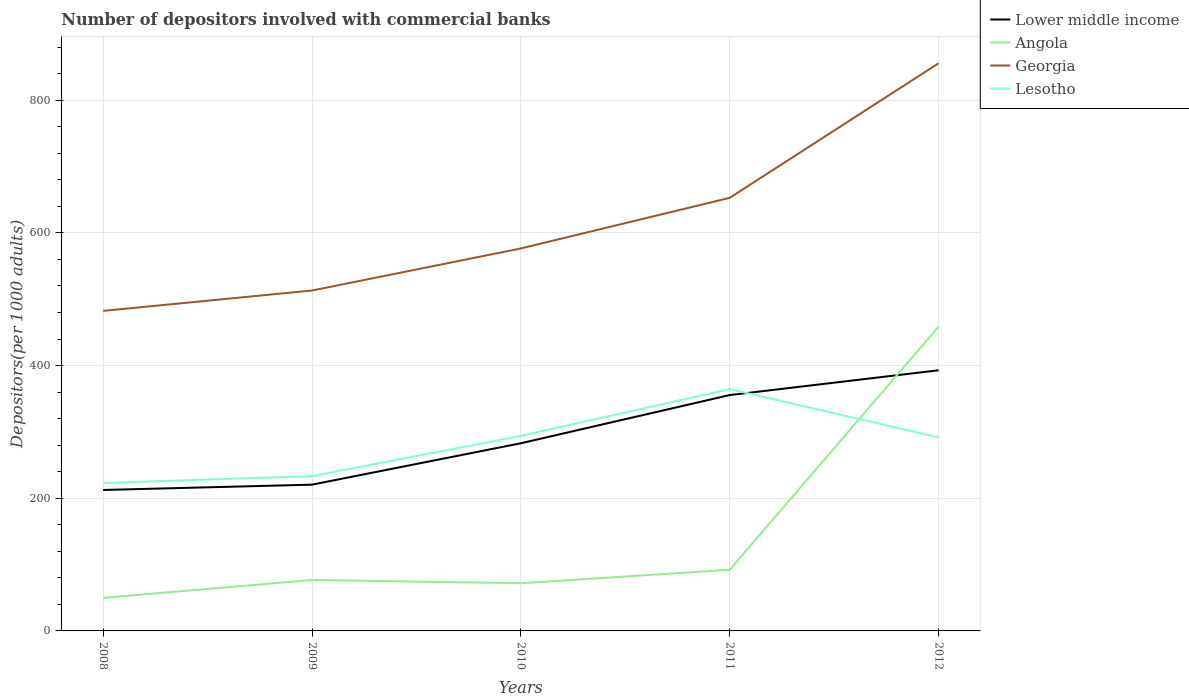How many different coloured lines are there?
Your response must be concise. 4. Does the line corresponding to Georgia intersect with the line corresponding to Lesotho?
Offer a terse response. No. Across all years, what is the maximum number of depositors involved with commercial banks in Angola?
Your answer should be compact. 49.81. In which year was the number of depositors involved with commercial banks in Georgia maximum?
Give a very brief answer. 2008. What is the total number of depositors involved with commercial banks in Georgia in the graph?
Your answer should be very brief. -202.83. What is the difference between the highest and the second highest number of depositors involved with commercial banks in Angola?
Your answer should be compact. 408.87. What is the difference between the highest and the lowest number of depositors involved with commercial banks in Lesotho?
Your response must be concise. 3. How many years are there in the graph?
Your response must be concise. 5. Are the values on the major ticks of Y-axis written in scientific E-notation?
Provide a succinct answer. No. Does the graph contain any zero values?
Your answer should be very brief. No. Where does the legend appear in the graph?
Keep it short and to the point. Top right. What is the title of the graph?
Offer a terse response. Number of depositors involved with commercial banks. What is the label or title of the X-axis?
Provide a short and direct response. Years. What is the label or title of the Y-axis?
Ensure brevity in your answer.  Depositors(per 1000 adults). What is the Depositors(per 1000 adults) in Lower middle income in 2008?
Provide a short and direct response. 212.5. What is the Depositors(per 1000 adults) in Angola in 2008?
Keep it short and to the point. 49.81. What is the Depositors(per 1000 adults) in Georgia in 2008?
Ensure brevity in your answer.  482.47. What is the Depositors(per 1000 adults) in Lesotho in 2008?
Provide a short and direct response. 223. What is the Depositors(per 1000 adults) of Lower middle income in 2009?
Your response must be concise. 220.51. What is the Depositors(per 1000 adults) in Angola in 2009?
Offer a very short reply. 76.82. What is the Depositors(per 1000 adults) in Georgia in 2009?
Your response must be concise. 513.17. What is the Depositors(per 1000 adults) of Lesotho in 2009?
Keep it short and to the point. 233.31. What is the Depositors(per 1000 adults) of Lower middle income in 2010?
Offer a terse response. 282.91. What is the Depositors(per 1000 adults) of Angola in 2010?
Provide a succinct answer. 71.89. What is the Depositors(per 1000 adults) in Georgia in 2010?
Make the answer very short. 576.61. What is the Depositors(per 1000 adults) of Lesotho in 2010?
Make the answer very short. 294.05. What is the Depositors(per 1000 adults) in Lower middle income in 2011?
Make the answer very short. 355.56. What is the Depositors(per 1000 adults) of Angola in 2011?
Offer a terse response. 92.17. What is the Depositors(per 1000 adults) of Georgia in 2011?
Offer a very short reply. 652.89. What is the Depositors(per 1000 adults) in Lesotho in 2011?
Provide a short and direct response. 364.57. What is the Depositors(per 1000 adults) in Lower middle income in 2012?
Offer a very short reply. 392.92. What is the Depositors(per 1000 adults) of Angola in 2012?
Provide a succinct answer. 458.68. What is the Depositors(per 1000 adults) in Georgia in 2012?
Your response must be concise. 855.71. What is the Depositors(per 1000 adults) of Lesotho in 2012?
Ensure brevity in your answer.  291.78. Across all years, what is the maximum Depositors(per 1000 adults) in Lower middle income?
Give a very brief answer. 392.92. Across all years, what is the maximum Depositors(per 1000 adults) in Angola?
Make the answer very short. 458.68. Across all years, what is the maximum Depositors(per 1000 adults) of Georgia?
Your answer should be compact. 855.71. Across all years, what is the maximum Depositors(per 1000 adults) of Lesotho?
Your answer should be compact. 364.57. Across all years, what is the minimum Depositors(per 1000 adults) in Lower middle income?
Provide a succinct answer. 212.5. Across all years, what is the minimum Depositors(per 1000 adults) of Angola?
Keep it short and to the point. 49.81. Across all years, what is the minimum Depositors(per 1000 adults) in Georgia?
Your answer should be compact. 482.47. Across all years, what is the minimum Depositors(per 1000 adults) in Lesotho?
Give a very brief answer. 223. What is the total Depositors(per 1000 adults) of Lower middle income in the graph?
Offer a very short reply. 1464.4. What is the total Depositors(per 1000 adults) in Angola in the graph?
Provide a short and direct response. 749.37. What is the total Depositors(per 1000 adults) of Georgia in the graph?
Provide a short and direct response. 3080.84. What is the total Depositors(per 1000 adults) of Lesotho in the graph?
Your answer should be very brief. 1406.71. What is the difference between the Depositors(per 1000 adults) of Lower middle income in 2008 and that in 2009?
Your answer should be very brief. -8.01. What is the difference between the Depositors(per 1000 adults) of Angola in 2008 and that in 2009?
Provide a short and direct response. -27.01. What is the difference between the Depositors(per 1000 adults) of Georgia in 2008 and that in 2009?
Give a very brief answer. -30.7. What is the difference between the Depositors(per 1000 adults) of Lesotho in 2008 and that in 2009?
Your answer should be very brief. -10.3. What is the difference between the Depositors(per 1000 adults) of Lower middle income in 2008 and that in 2010?
Your response must be concise. -70.41. What is the difference between the Depositors(per 1000 adults) of Angola in 2008 and that in 2010?
Ensure brevity in your answer.  -22.08. What is the difference between the Depositors(per 1000 adults) of Georgia in 2008 and that in 2010?
Give a very brief answer. -94.14. What is the difference between the Depositors(per 1000 adults) in Lesotho in 2008 and that in 2010?
Provide a short and direct response. -71.05. What is the difference between the Depositors(per 1000 adults) in Lower middle income in 2008 and that in 2011?
Your answer should be compact. -143.06. What is the difference between the Depositors(per 1000 adults) of Angola in 2008 and that in 2011?
Keep it short and to the point. -42.36. What is the difference between the Depositors(per 1000 adults) in Georgia in 2008 and that in 2011?
Ensure brevity in your answer.  -170.42. What is the difference between the Depositors(per 1000 adults) of Lesotho in 2008 and that in 2011?
Your response must be concise. -141.56. What is the difference between the Depositors(per 1000 adults) of Lower middle income in 2008 and that in 2012?
Your answer should be compact. -180.42. What is the difference between the Depositors(per 1000 adults) in Angola in 2008 and that in 2012?
Keep it short and to the point. -408.87. What is the difference between the Depositors(per 1000 adults) in Georgia in 2008 and that in 2012?
Your answer should be very brief. -373.25. What is the difference between the Depositors(per 1000 adults) of Lesotho in 2008 and that in 2012?
Your answer should be very brief. -68.78. What is the difference between the Depositors(per 1000 adults) in Lower middle income in 2009 and that in 2010?
Your answer should be very brief. -62.4. What is the difference between the Depositors(per 1000 adults) of Angola in 2009 and that in 2010?
Your response must be concise. 4.93. What is the difference between the Depositors(per 1000 adults) in Georgia in 2009 and that in 2010?
Provide a succinct answer. -63.44. What is the difference between the Depositors(per 1000 adults) in Lesotho in 2009 and that in 2010?
Your answer should be very brief. -60.75. What is the difference between the Depositors(per 1000 adults) in Lower middle income in 2009 and that in 2011?
Your answer should be very brief. -135.05. What is the difference between the Depositors(per 1000 adults) of Angola in 2009 and that in 2011?
Your response must be concise. -15.36. What is the difference between the Depositors(per 1000 adults) of Georgia in 2009 and that in 2011?
Ensure brevity in your answer.  -139.72. What is the difference between the Depositors(per 1000 adults) of Lesotho in 2009 and that in 2011?
Ensure brevity in your answer.  -131.26. What is the difference between the Depositors(per 1000 adults) in Lower middle income in 2009 and that in 2012?
Offer a very short reply. -172.41. What is the difference between the Depositors(per 1000 adults) of Angola in 2009 and that in 2012?
Offer a very short reply. -381.87. What is the difference between the Depositors(per 1000 adults) in Georgia in 2009 and that in 2012?
Offer a terse response. -342.55. What is the difference between the Depositors(per 1000 adults) in Lesotho in 2009 and that in 2012?
Your answer should be compact. -58.47. What is the difference between the Depositors(per 1000 adults) of Lower middle income in 2010 and that in 2011?
Keep it short and to the point. -72.64. What is the difference between the Depositors(per 1000 adults) in Angola in 2010 and that in 2011?
Ensure brevity in your answer.  -20.29. What is the difference between the Depositors(per 1000 adults) in Georgia in 2010 and that in 2011?
Your answer should be compact. -76.28. What is the difference between the Depositors(per 1000 adults) in Lesotho in 2010 and that in 2011?
Provide a succinct answer. -70.51. What is the difference between the Depositors(per 1000 adults) of Lower middle income in 2010 and that in 2012?
Make the answer very short. -110.01. What is the difference between the Depositors(per 1000 adults) of Angola in 2010 and that in 2012?
Your response must be concise. -386.79. What is the difference between the Depositors(per 1000 adults) in Georgia in 2010 and that in 2012?
Ensure brevity in your answer.  -279.11. What is the difference between the Depositors(per 1000 adults) of Lesotho in 2010 and that in 2012?
Offer a very short reply. 2.27. What is the difference between the Depositors(per 1000 adults) in Lower middle income in 2011 and that in 2012?
Keep it short and to the point. -37.36. What is the difference between the Depositors(per 1000 adults) in Angola in 2011 and that in 2012?
Offer a very short reply. -366.51. What is the difference between the Depositors(per 1000 adults) in Georgia in 2011 and that in 2012?
Your answer should be very brief. -202.83. What is the difference between the Depositors(per 1000 adults) of Lesotho in 2011 and that in 2012?
Provide a short and direct response. 72.79. What is the difference between the Depositors(per 1000 adults) in Lower middle income in 2008 and the Depositors(per 1000 adults) in Angola in 2009?
Your answer should be very brief. 135.68. What is the difference between the Depositors(per 1000 adults) of Lower middle income in 2008 and the Depositors(per 1000 adults) of Georgia in 2009?
Offer a terse response. -300.66. What is the difference between the Depositors(per 1000 adults) of Lower middle income in 2008 and the Depositors(per 1000 adults) of Lesotho in 2009?
Give a very brief answer. -20.81. What is the difference between the Depositors(per 1000 adults) of Angola in 2008 and the Depositors(per 1000 adults) of Georgia in 2009?
Give a very brief answer. -463.35. What is the difference between the Depositors(per 1000 adults) of Angola in 2008 and the Depositors(per 1000 adults) of Lesotho in 2009?
Give a very brief answer. -183.5. What is the difference between the Depositors(per 1000 adults) of Georgia in 2008 and the Depositors(per 1000 adults) of Lesotho in 2009?
Make the answer very short. 249.16. What is the difference between the Depositors(per 1000 adults) of Lower middle income in 2008 and the Depositors(per 1000 adults) of Angola in 2010?
Your response must be concise. 140.61. What is the difference between the Depositors(per 1000 adults) in Lower middle income in 2008 and the Depositors(per 1000 adults) in Georgia in 2010?
Make the answer very short. -364.11. What is the difference between the Depositors(per 1000 adults) in Lower middle income in 2008 and the Depositors(per 1000 adults) in Lesotho in 2010?
Provide a short and direct response. -81.55. What is the difference between the Depositors(per 1000 adults) in Angola in 2008 and the Depositors(per 1000 adults) in Georgia in 2010?
Keep it short and to the point. -526.8. What is the difference between the Depositors(per 1000 adults) of Angola in 2008 and the Depositors(per 1000 adults) of Lesotho in 2010?
Ensure brevity in your answer.  -244.24. What is the difference between the Depositors(per 1000 adults) of Georgia in 2008 and the Depositors(per 1000 adults) of Lesotho in 2010?
Your response must be concise. 188.41. What is the difference between the Depositors(per 1000 adults) in Lower middle income in 2008 and the Depositors(per 1000 adults) in Angola in 2011?
Your response must be concise. 120.33. What is the difference between the Depositors(per 1000 adults) of Lower middle income in 2008 and the Depositors(per 1000 adults) of Georgia in 2011?
Keep it short and to the point. -440.39. What is the difference between the Depositors(per 1000 adults) of Lower middle income in 2008 and the Depositors(per 1000 adults) of Lesotho in 2011?
Offer a terse response. -152.07. What is the difference between the Depositors(per 1000 adults) of Angola in 2008 and the Depositors(per 1000 adults) of Georgia in 2011?
Provide a short and direct response. -603.08. What is the difference between the Depositors(per 1000 adults) in Angola in 2008 and the Depositors(per 1000 adults) in Lesotho in 2011?
Offer a terse response. -314.76. What is the difference between the Depositors(per 1000 adults) of Georgia in 2008 and the Depositors(per 1000 adults) of Lesotho in 2011?
Your answer should be compact. 117.9. What is the difference between the Depositors(per 1000 adults) of Lower middle income in 2008 and the Depositors(per 1000 adults) of Angola in 2012?
Ensure brevity in your answer.  -246.18. What is the difference between the Depositors(per 1000 adults) of Lower middle income in 2008 and the Depositors(per 1000 adults) of Georgia in 2012?
Offer a terse response. -643.21. What is the difference between the Depositors(per 1000 adults) in Lower middle income in 2008 and the Depositors(per 1000 adults) in Lesotho in 2012?
Your answer should be compact. -79.28. What is the difference between the Depositors(per 1000 adults) of Angola in 2008 and the Depositors(per 1000 adults) of Georgia in 2012?
Make the answer very short. -805.9. What is the difference between the Depositors(per 1000 adults) in Angola in 2008 and the Depositors(per 1000 adults) in Lesotho in 2012?
Your answer should be very brief. -241.97. What is the difference between the Depositors(per 1000 adults) in Georgia in 2008 and the Depositors(per 1000 adults) in Lesotho in 2012?
Your answer should be very brief. 190.69. What is the difference between the Depositors(per 1000 adults) in Lower middle income in 2009 and the Depositors(per 1000 adults) in Angola in 2010?
Your answer should be very brief. 148.62. What is the difference between the Depositors(per 1000 adults) of Lower middle income in 2009 and the Depositors(per 1000 adults) of Georgia in 2010?
Offer a very short reply. -356.1. What is the difference between the Depositors(per 1000 adults) of Lower middle income in 2009 and the Depositors(per 1000 adults) of Lesotho in 2010?
Ensure brevity in your answer.  -73.54. What is the difference between the Depositors(per 1000 adults) in Angola in 2009 and the Depositors(per 1000 adults) in Georgia in 2010?
Give a very brief answer. -499.79. What is the difference between the Depositors(per 1000 adults) of Angola in 2009 and the Depositors(per 1000 adults) of Lesotho in 2010?
Give a very brief answer. -217.24. What is the difference between the Depositors(per 1000 adults) of Georgia in 2009 and the Depositors(per 1000 adults) of Lesotho in 2010?
Make the answer very short. 219.11. What is the difference between the Depositors(per 1000 adults) in Lower middle income in 2009 and the Depositors(per 1000 adults) in Angola in 2011?
Your answer should be compact. 128.34. What is the difference between the Depositors(per 1000 adults) in Lower middle income in 2009 and the Depositors(per 1000 adults) in Georgia in 2011?
Make the answer very short. -432.38. What is the difference between the Depositors(per 1000 adults) of Lower middle income in 2009 and the Depositors(per 1000 adults) of Lesotho in 2011?
Make the answer very short. -144.06. What is the difference between the Depositors(per 1000 adults) in Angola in 2009 and the Depositors(per 1000 adults) in Georgia in 2011?
Offer a terse response. -576.07. What is the difference between the Depositors(per 1000 adults) in Angola in 2009 and the Depositors(per 1000 adults) in Lesotho in 2011?
Your answer should be compact. -287.75. What is the difference between the Depositors(per 1000 adults) in Georgia in 2009 and the Depositors(per 1000 adults) in Lesotho in 2011?
Offer a very short reply. 148.6. What is the difference between the Depositors(per 1000 adults) of Lower middle income in 2009 and the Depositors(per 1000 adults) of Angola in 2012?
Ensure brevity in your answer.  -238.17. What is the difference between the Depositors(per 1000 adults) of Lower middle income in 2009 and the Depositors(per 1000 adults) of Georgia in 2012?
Ensure brevity in your answer.  -635.2. What is the difference between the Depositors(per 1000 adults) in Lower middle income in 2009 and the Depositors(per 1000 adults) in Lesotho in 2012?
Ensure brevity in your answer.  -71.27. What is the difference between the Depositors(per 1000 adults) of Angola in 2009 and the Depositors(per 1000 adults) of Georgia in 2012?
Your response must be concise. -778.9. What is the difference between the Depositors(per 1000 adults) of Angola in 2009 and the Depositors(per 1000 adults) of Lesotho in 2012?
Give a very brief answer. -214.96. What is the difference between the Depositors(per 1000 adults) in Georgia in 2009 and the Depositors(per 1000 adults) in Lesotho in 2012?
Provide a short and direct response. 221.39. What is the difference between the Depositors(per 1000 adults) in Lower middle income in 2010 and the Depositors(per 1000 adults) in Angola in 2011?
Give a very brief answer. 190.74. What is the difference between the Depositors(per 1000 adults) in Lower middle income in 2010 and the Depositors(per 1000 adults) in Georgia in 2011?
Offer a very short reply. -369.97. What is the difference between the Depositors(per 1000 adults) of Lower middle income in 2010 and the Depositors(per 1000 adults) of Lesotho in 2011?
Your answer should be compact. -81.66. What is the difference between the Depositors(per 1000 adults) of Angola in 2010 and the Depositors(per 1000 adults) of Georgia in 2011?
Provide a short and direct response. -581. What is the difference between the Depositors(per 1000 adults) in Angola in 2010 and the Depositors(per 1000 adults) in Lesotho in 2011?
Your answer should be compact. -292.68. What is the difference between the Depositors(per 1000 adults) in Georgia in 2010 and the Depositors(per 1000 adults) in Lesotho in 2011?
Ensure brevity in your answer.  212.04. What is the difference between the Depositors(per 1000 adults) of Lower middle income in 2010 and the Depositors(per 1000 adults) of Angola in 2012?
Keep it short and to the point. -175.77. What is the difference between the Depositors(per 1000 adults) of Lower middle income in 2010 and the Depositors(per 1000 adults) of Georgia in 2012?
Your answer should be compact. -572.8. What is the difference between the Depositors(per 1000 adults) of Lower middle income in 2010 and the Depositors(per 1000 adults) of Lesotho in 2012?
Your response must be concise. -8.87. What is the difference between the Depositors(per 1000 adults) in Angola in 2010 and the Depositors(per 1000 adults) in Georgia in 2012?
Offer a terse response. -783.83. What is the difference between the Depositors(per 1000 adults) of Angola in 2010 and the Depositors(per 1000 adults) of Lesotho in 2012?
Keep it short and to the point. -219.89. What is the difference between the Depositors(per 1000 adults) in Georgia in 2010 and the Depositors(per 1000 adults) in Lesotho in 2012?
Provide a succinct answer. 284.83. What is the difference between the Depositors(per 1000 adults) in Lower middle income in 2011 and the Depositors(per 1000 adults) in Angola in 2012?
Provide a short and direct response. -103.13. What is the difference between the Depositors(per 1000 adults) in Lower middle income in 2011 and the Depositors(per 1000 adults) in Georgia in 2012?
Provide a short and direct response. -500.16. What is the difference between the Depositors(per 1000 adults) of Lower middle income in 2011 and the Depositors(per 1000 adults) of Lesotho in 2012?
Your answer should be very brief. 63.78. What is the difference between the Depositors(per 1000 adults) in Angola in 2011 and the Depositors(per 1000 adults) in Georgia in 2012?
Offer a very short reply. -763.54. What is the difference between the Depositors(per 1000 adults) in Angola in 2011 and the Depositors(per 1000 adults) in Lesotho in 2012?
Ensure brevity in your answer.  -199.61. What is the difference between the Depositors(per 1000 adults) in Georgia in 2011 and the Depositors(per 1000 adults) in Lesotho in 2012?
Your response must be concise. 361.11. What is the average Depositors(per 1000 adults) of Lower middle income per year?
Provide a succinct answer. 292.88. What is the average Depositors(per 1000 adults) in Angola per year?
Keep it short and to the point. 149.87. What is the average Depositors(per 1000 adults) in Georgia per year?
Your response must be concise. 616.17. What is the average Depositors(per 1000 adults) in Lesotho per year?
Ensure brevity in your answer.  281.34. In the year 2008, what is the difference between the Depositors(per 1000 adults) of Lower middle income and Depositors(per 1000 adults) of Angola?
Offer a terse response. 162.69. In the year 2008, what is the difference between the Depositors(per 1000 adults) of Lower middle income and Depositors(per 1000 adults) of Georgia?
Give a very brief answer. -269.97. In the year 2008, what is the difference between the Depositors(per 1000 adults) in Lower middle income and Depositors(per 1000 adults) in Lesotho?
Give a very brief answer. -10.5. In the year 2008, what is the difference between the Depositors(per 1000 adults) of Angola and Depositors(per 1000 adults) of Georgia?
Your answer should be very brief. -432.66. In the year 2008, what is the difference between the Depositors(per 1000 adults) of Angola and Depositors(per 1000 adults) of Lesotho?
Offer a very short reply. -173.19. In the year 2008, what is the difference between the Depositors(per 1000 adults) of Georgia and Depositors(per 1000 adults) of Lesotho?
Your answer should be compact. 259.47. In the year 2009, what is the difference between the Depositors(per 1000 adults) in Lower middle income and Depositors(per 1000 adults) in Angola?
Provide a succinct answer. 143.69. In the year 2009, what is the difference between the Depositors(per 1000 adults) in Lower middle income and Depositors(per 1000 adults) in Georgia?
Make the answer very short. -292.66. In the year 2009, what is the difference between the Depositors(per 1000 adults) of Lower middle income and Depositors(per 1000 adults) of Lesotho?
Provide a short and direct response. -12.8. In the year 2009, what is the difference between the Depositors(per 1000 adults) of Angola and Depositors(per 1000 adults) of Georgia?
Your answer should be compact. -436.35. In the year 2009, what is the difference between the Depositors(per 1000 adults) in Angola and Depositors(per 1000 adults) in Lesotho?
Your response must be concise. -156.49. In the year 2009, what is the difference between the Depositors(per 1000 adults) of Georgia and Depositors(per 1000 adults) of Lesotho?
Provide a succinct answer. 279.86. In the year 2010, what is the difference between the Depositors(per 1000 adults) in Lower middle income and Depositors(per 1000 adults) in Angola?
Provide a succinct answer. 211.02. In the year 2010, what is the difference between the Depositors(per 1000 adults) in Lower middle income and Depositors(per 1000 adults) in Georgia?
Your answer should be compact. -293.7. In the year 2010, what is the difference between the Depositors(per 1000 adults) in Lower middle income and Depositors(per 1000 adults) in Lesotho?
Your answer should be compact. -11.14. In the year 2010, what is the difference between the Depositors(per 1000 adults) in Angola and Depositors(per 1000 adults) in Georgia?
Provide a short and direct response. -504.72. In the year 2010, what is the difference between the Depositors(per 1000 adults) of Angola and Depositors(per 1000 adults) of Lesotho?
Offer a terse response. -222.17. In the year 2010, what is the difference between the Depositors(per 1000 adults) in Georgia and Depositors(per 1000 adults) in Lesotho?
Make the answer very short. 282.55. In the year 2011, what is the difference between the Depositors(per 1000 adults) in Lower middle income and Depositors(per 1000 adults) in Angola?
Your answer should be compact. 263.38. In the year 2011, what is the difference between the Depositors(per 1000 adults) in Lower middle income and Depositors(per 1000 adults) in Georgia?
Your response must be concise. -297.33. In the year 2011, what is the difference between the Depositors(per 1000 adults) in Lower middle income and Depositors(per 1000 adults) in Lesotho?
Your response must be concise. -9.01. In the year 2011, what is the difference between the Depositors(per 1000 adults) of Angola and Depositors(per 1000 adults) of Georgia?
Your answer should be very brief. -560.71. In the year 2011, what is the difference between the Depositors(per 1000 adults) of Angola and Depositors(per 1000 adults) of Lesotho?
Your response must be concise. -272.39. In the year 2011, what is the difference between the Depositors(per 1000 adults) of Georgia and Depositors(per 1000 adults) of Lesotho?
Give a very brief answer. 288.32. In the year 2012, what is the difference between the Depositors(per 1000 adults) in Lower middle income and Depositors(per 1000 adults) in Angola?
Provide a short and direct response. -65.76. In the year 2012, what is the difference between the Depositors(per 1000 adults) in Lower middle income and Depositors(per 1000 adults) in Georgia?
Give a very brief answer. -462.79. In the year 2012, what is the difference between the Depositors(per 1000 adults) in Lower middle income and Depositors(per 1000 adults) in Lesotho?
Provide a short and direct response. 101.14. In the year 2012, what is the difference between the Depositors(per 1000 adults) of Angola and Depositors(per 1000 adults) of Georgia?
Ensure brevity in your answer.  -397.03. In the year 2012, what is the difference between the Depositors(per 1000 adults) in Angola and Depositors(per 1000 adults) in Lesotho?
Offer a terse response. 166.9. In the year 2012, what is the difference between the Depositors(per 1000 adults) of Georgia and Depositors(per 1000 adults) of Lesotho?
Ensure brevity in your answer.  563.93. What is the ratio of the Depositors(per 1000 adults) in Lower middle income in 2008 to that in 2009?
Your response must be concise. 0.96. What is the ratio of the Depositors(per 1000 adults) of Angola in 2008 to that in 2009?
Provide a succinct answer. 0.65. What is the ratio of the Depositors(per 1000 adults) in Georgia in 2008 to that in 2009?
Give a very brief answer. 0.94. What is the ratio of the Depositors(per 1000 adults) in Lesotho in 2008 to that in 2009?
Your response must be concise. 0.96. What is the ratio of the Depositors(per 1000 adults) in Lower middle income in 2008 to that in 2010?
Provide a short and direct response. 0.75. What is the ratio of the Depositors(per 1000 adults) of Angola in 2008 to that in 2010?
Give a very brief answer. 0.69. What is the ratio of the Depositors(per 1000 adults) of Georgia in 2008 to that in 2010?
Offer a terse response. 0.84. What is the ratio of the Depositors(per 1000 adults) of Lesotho in 2008 to that in 2010?
Provide a short and direct response. 0.76. What is the ratio of the Depositors(per 1000 adults) in Lower middle income in 2008 to that in 2011?
Your answer should be very brief. 0.6. What is the ratio of the Depositors(per 1000 adults) of Angola in 2008 to that in 2011?
Your response must be concise. 0.54. What is the ratio of the Depositors(per 1000 adults) in Georgia in 2008 to that in 2011?
Provide a short and direct response. 0.74. What is the ratio of the Depositors(per 1000 adults) of Lesotho in 2008 to that in 2011?
Your response must be concise. 0.61. What is the ratio of the Depositors(per 1000 adults) of Lower middle income in 2008 to that in 2012?
Provide a succinct answer. 0.54. What is the ratio of the Depositors(per 1000 adults) of Angola in 2008 to that in 2012?
Offer a very short reply. 0.11. What is the ratio of the Depositors(per 1000 adults) in Georgia in 2008 to that in 2012?
Your answer should be very brief. 0.56. What is the ratio of the Depositors(per 1000 adults) in Lesotho in 2008 to that in 2012?
Offer a terse response. 0.76. What is the ratio of the Depositors(per 1000 adults) in Lower middle income in 2009 to that in 2010?
Give a very brief answer. 0.78. What is the ratio of the Depositors(per 1000 adults) in Angola in 2009 to that in 2010?
Offer a terse response. 1.07. What is the ratio of the Depositors(per 1000 adults) of Georgia in 2009 to that in 2010?
Make the answer very short. 0.89. What is the ratio of the Depositors(per 1000 adults) of Lesotho in 2009 to that in 2010?
Make the answer very short. 0.79. What is the ratio of the Depositors(per 1000 adults) in Lower middle income in 2009 to that in 2011?
Provide a short and direct response. 0.62. What is the ratio of the Depositors(per 1000 adults) in Angola in 2009 to that in 2011?
Provide a succinct answer. 0.83. What is the ratio of the Depositors(per 1000 adults) of Georgia in 2009 to that in 2011?
Keep it short and to the point. 0.79. What is the ratio of the Depositors(per 1000 adults) in Lesotho in 2009 to that in 2011?
Give a very brief answer. 0.64. What is the ratio of the Depositors(per 1000 adults) in Lower middle income in 2009 to that in 2012?
Ensure brevity in your answer.  0.56. What is the ratio of the Depositors(per 1000 adults) in Angola in 2009 to that in 2012?
Your response must be concise. 0.17. What is the ratio of the Depositors(per 1000 adults) of Georgia in 2009 to that in 2012?
Give a very brief answer. 0.6. What is the ratio of the Depositors(per 1000 adults) in Lesotho in 2009 to that in 2012?
Offer a very short reply. 0.8. What is the ratio of the Depositors(per 1000 adults) of Lower middle income in 2010 to that in 2011?
Ensure brevity in your answer.  0.8. What is the ratio of the Depositors(per 1000 adults) in Angola in 2010 to that in 2011?
Your response must be concise. 0.78. What is the ratio of the Depositors(per 1000 adults) in Georgia in 2010 to that in 2011?
Your answer should be very brief. 0.88. What is the ratio of the Depositors(per 1000 adults) in Lesotho in 2010 to that in 2011?
Provide a succinct answer. 0.81. What is the ratio of the Depositors(per 1000 adults) of Lower middle income in 2010 to that in 2012?
Ensure brevity in your answer.  0.72. What is the ratio of the Depositors(per 1000 adults) in Angola in 2010 to that in 2012?
Make the answer very short. 0.16. What is the ratio of the Depositors(per 1000 adults) of Georgia in 2010 to that in 2012?
Provide a succinct answer. 0.67. What is the ratio of the Depositors(per 1000 adults) of Lesotho in 2010 to that in 2012?
Provide a succinct answer. 1.01. What is the ratio of the Depositors(per 1000 adults) in Lower middle income in 2011 to that in 2012?
Ensure brevity in your answer.  0.9. What is the ratio of the Depositors(per 1000 adults) of Angola in 2011 to that in 2012?
Your response must be concise. 0.2. What is the ratio of the Depositors(per 1000 adults) in Georgia in 2011 to that in 2012?
Offer a very short reply. 0.76. What is the ratio of the Depositors(per 1000 adults) in Lesotho in 2011 to that in 2012?
Provide a succinct answer. 1.25. What is the difference between the highest and the second highest Depositors(per 1000 adults) of Lower middle income?
Give a very brief answer. 37.36. What is the difference between the highest and the second highest Depositors(per 1000 adults) of Angola?
Ensure brevity in your answer.  366.51. What is the difference between the highest and the second highest Depositors(per 1000 adults) of Georgia?
Provide a short and direct response. 202.83. What is the difference between the highest and the second highest Depositors(per 1000 adults) in Lesotho?
Your answer should be very brief. 70.51. What is the difference between the highest and the lowest Depositors(per 1000 adults) in Lower middle income?
Ensure brevity in your answer.  180.42. What is the difference between the highest and the lowest Depositors(per 1000 adults) of Angola?
Give a very brief answer. 408.87. What is the difference between the highest and the lowest Depositors(per 1000 adults) of Georgia?
Provide a succinct answer. 373.25. What is the difference between the highest and the lowest Depositors(per 1000 adults) in Lesotho?
Offer a terse response. 141.56. 